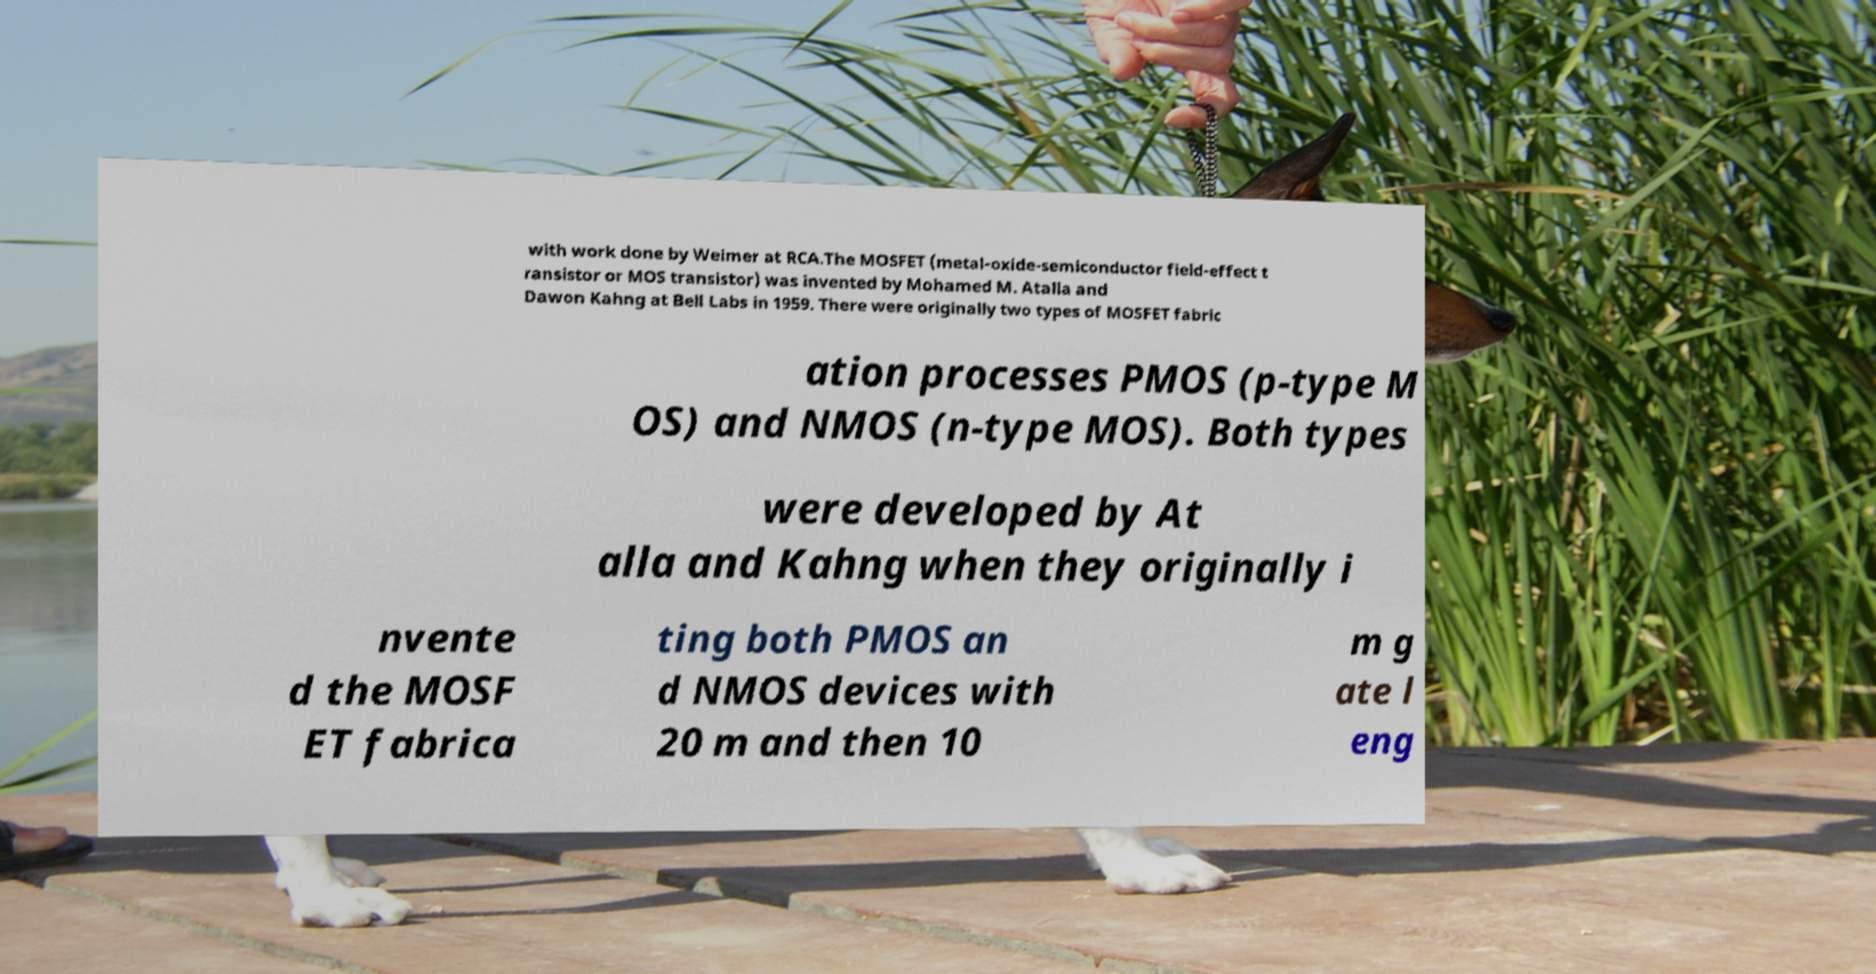I need the written content from this picture converted into text. Can you do that? with work done by Weimer at RCA.The MOSFET (metal-oxide-semiconductor field-effect t ransistor or MOS transistor) was invented by Mohamed M. Atalla and Dawon Kahng at Bell Labs in 1959. There were originally two types of MOSFET fabric ation processes PMOS (p-type M OS) and NMOS (n-type MOS). Both types were developed by At alla and Kahng when they originally i nvente d the MOSF ET fabrica ting both PMOS an d NMOS devices with 20 m and then 10 m g ate l eng 